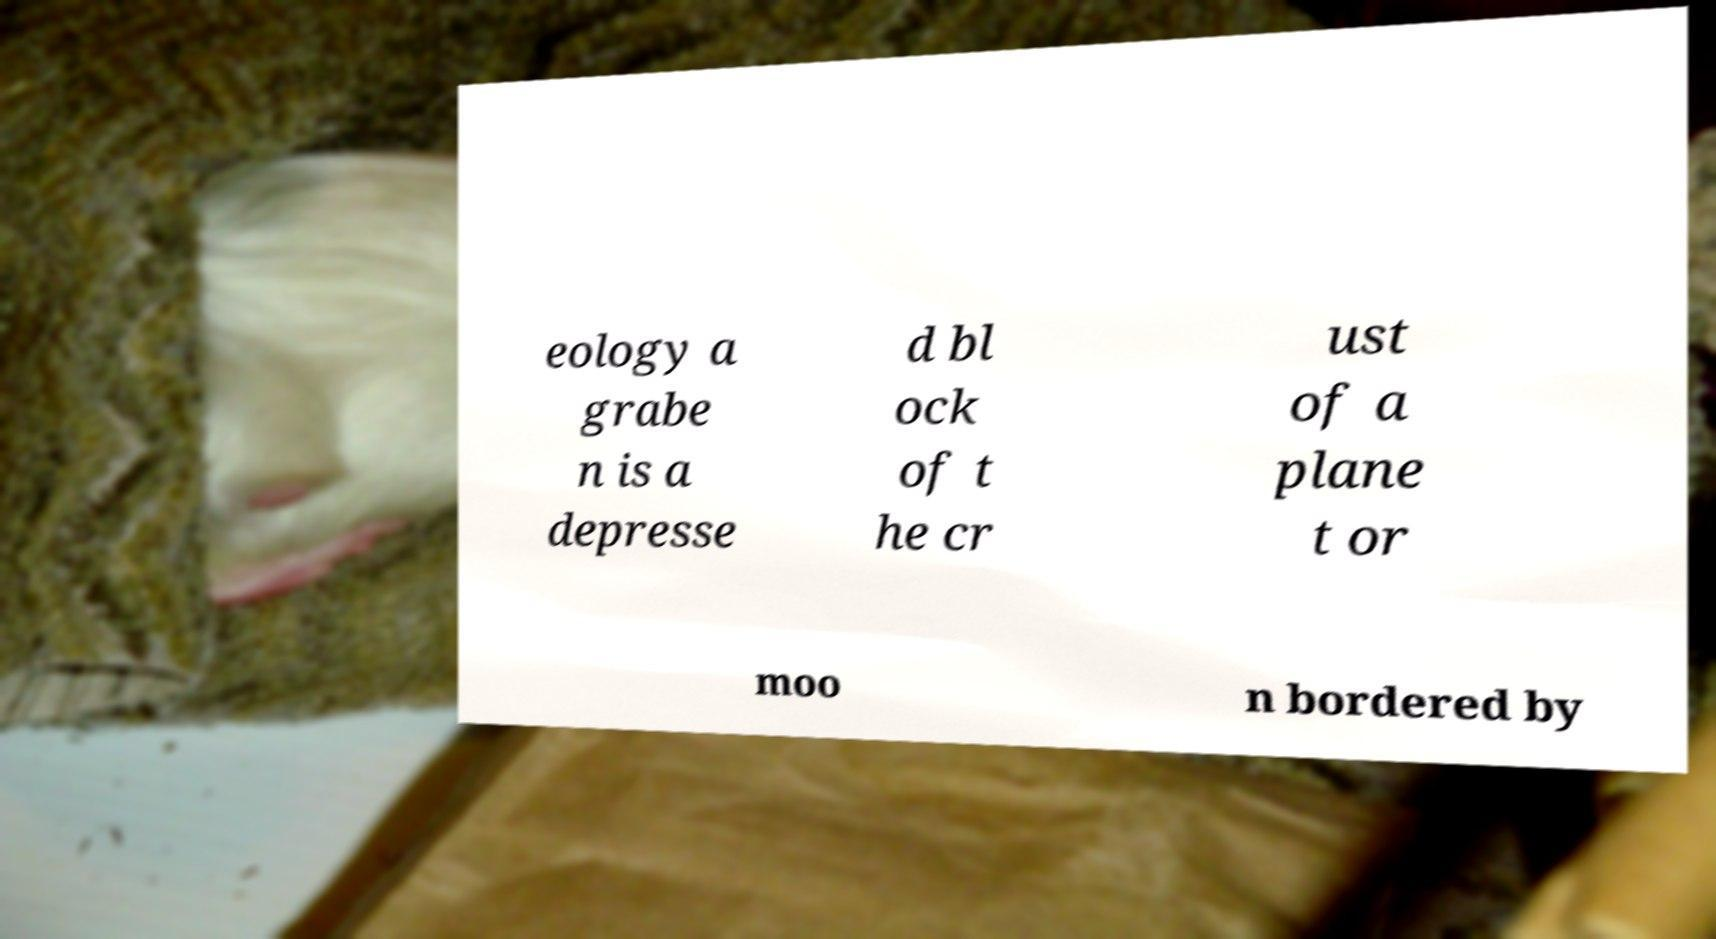Can you accurately transcribe the text from the provided image for me? eology a grabe n is a depresse d bl ock of t he cr ust of a plane t or moo n bordered by 